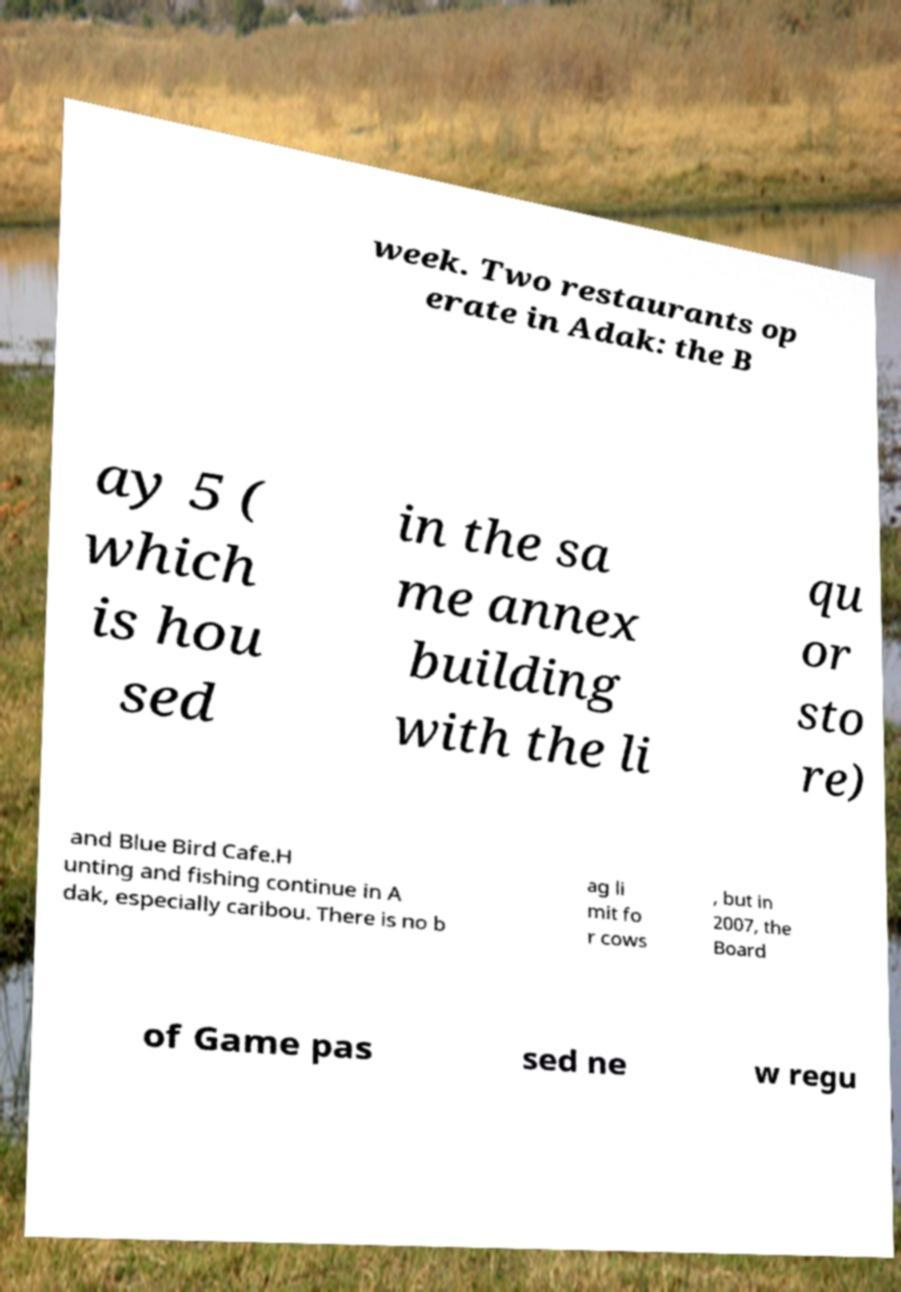Can you read and provide the text displayed in the image?This photo seems to have some interesting text. Can you extract and type it out for me? week. Two restaurants op erate in Adak: the B ay 5 ( which is hou sed in the sa me annex building with the li qu or sto re) and Blue Bird Cafe.H unting and fishing continue in A dak, especially caribou. There is no b ag li mit fo r cows , but in 2007, the Board of Game pas sed ne w regu 